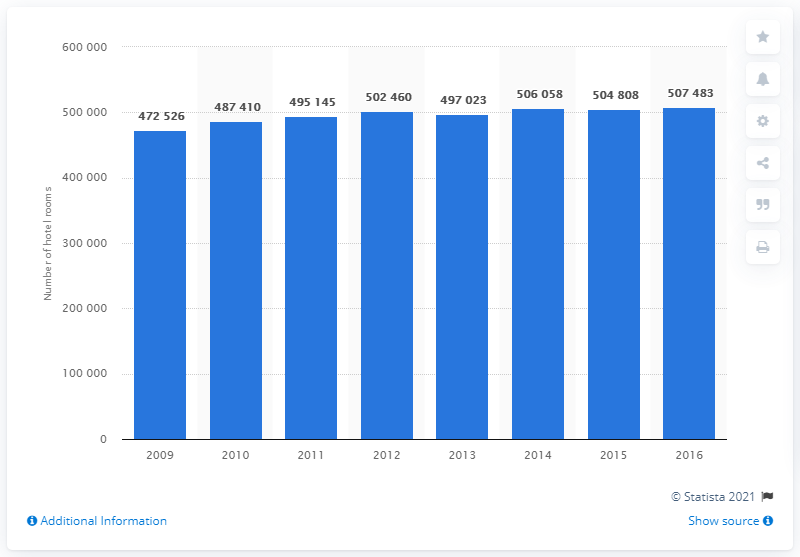Highlight a few significant elements in this photo. As of January 1, 2014, there were 507,483 hotel rooms in Choice Hotels International. 